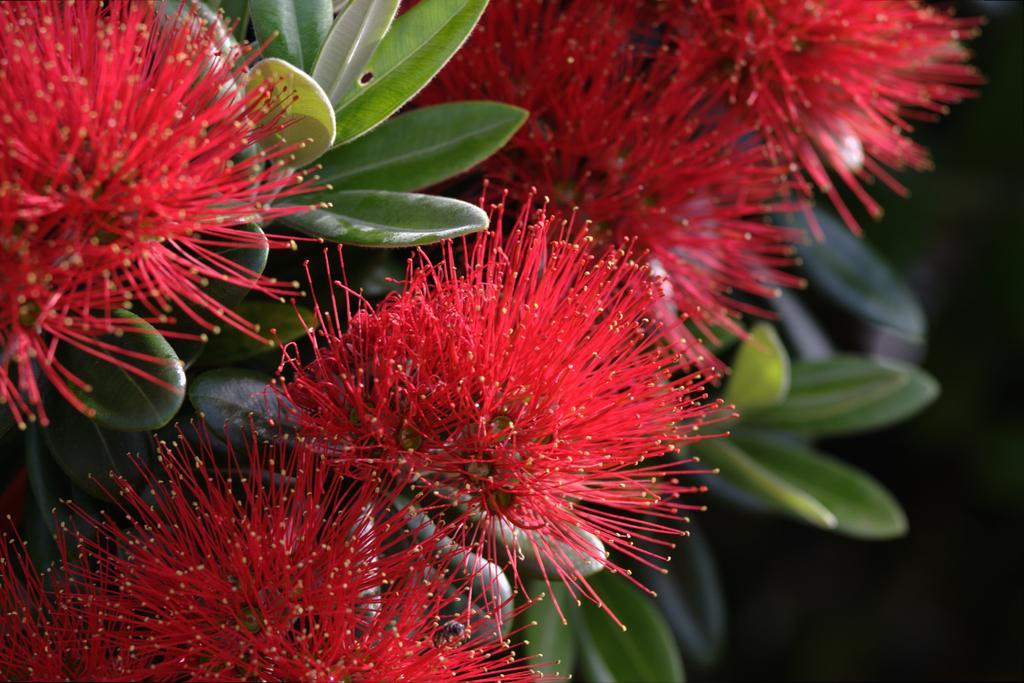Describe this image in one or two sentences. In this image we can see some flowers and leaves. 